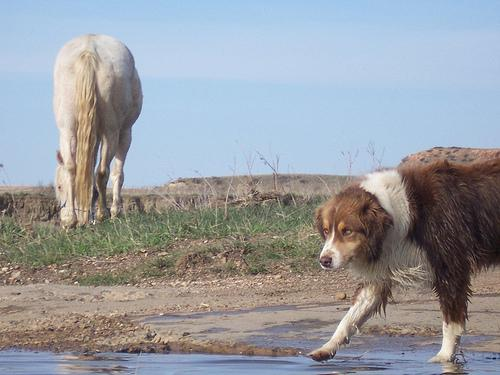Count the total number of dogs and horses in the image and describe their surroundings. There is one dog and one horse in the image, surrounded by green grass, brown dirt, and blue water near the riverbank under a bright blue sky. Provide a brief description of the scenery in the image. The image shows a white horse grazing on grass and a brown and white dog standing near the riverbank, with green grass, brown dirt, and blue sky in the background. Tell me about the dog in the image and an action it is doing. The dog in the image is brown and white with a wet paw over water, and it is standing in the blue water near the riverbank. In the image, describe the landscapes' features and the color of the sky. The landscape features green grass, brown dirt, a rocky and muddy riverbank, and stony areas near the river, while the sky is both clear and blue. Examine the image and explain the connection between the dog and the water. The dog is standing in the water with a wet paw and is interacting with the water by wading in the blue river near the grassy and stony area. Analyze the sentiment and atmosphere of the scene within the image. The scene has a peaceful and serene atmosphere with the horse grazing on the grass and the dog gently wading in the river on a clear day. Identify the main animals in the image and their distinct characteristics. The main animals are a brown and white dog with a wet paw and a brown nose, and a white horse with a blonde tail and a reflection in the water. What are the two main animals seen in the image, and what are they doing? The two main animals are a brown and white dog wading in the river and a white horse grazing on grass close to the riverbank. Describe the primary colors and objects that compose most of the image's area. The primary colors of the image are blue (water and sky), green (grass), brown (dirt and some parts of the dog), and white (horse). The main objects are the horse, dog, grass, dirt, water, and sky. Mention the main objects in the image and their corresponding colors. The main objects are the brown and white dog, the white horse, brown dirt, green grass, blue water, and a bright blue sky. 